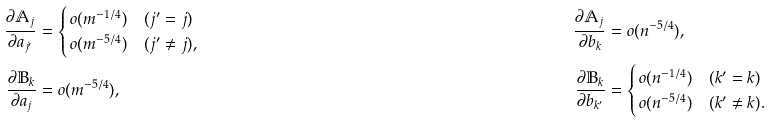Convert formula to latex. <formula><loc_0><loc_0><loc_500><loc_500>\frac { \partial \mathbb { A } _ { j } } { \partial a _ { j ^ { \prime } } } & = \begin{cases} \, o ( m ^ { - 1 / 4 } ) & ( j ^ { \prime } = j ) \\ \, o ( m ^ { - 5 / 4 } ) & ( j ^ { \prime } \ne j ) , \end{cases} & \frac { \partial \mathbb { A } _ { j } } { \partial b _ { k } } & = o ( n ^ { - 5 / 4 } ) , \\ \frac { \partial \mathbb { B } _ { k } } { \partial a _ { j } } & = o ( m ^ { - 5 / 4 } ) , & \frac { \partial \mathbb { B } _ { k } } { \partial b _ { k ^ { \prime } } } & = \begin{cases} \, o ( n ^ { - 1 / 4 } ) & ( k ^ { \prime } = k ) \\ \, o ( n ^ { - 5 / 4 } ) & ( k ^ { \prime } \ne k ) . \end{cases}</formula> 